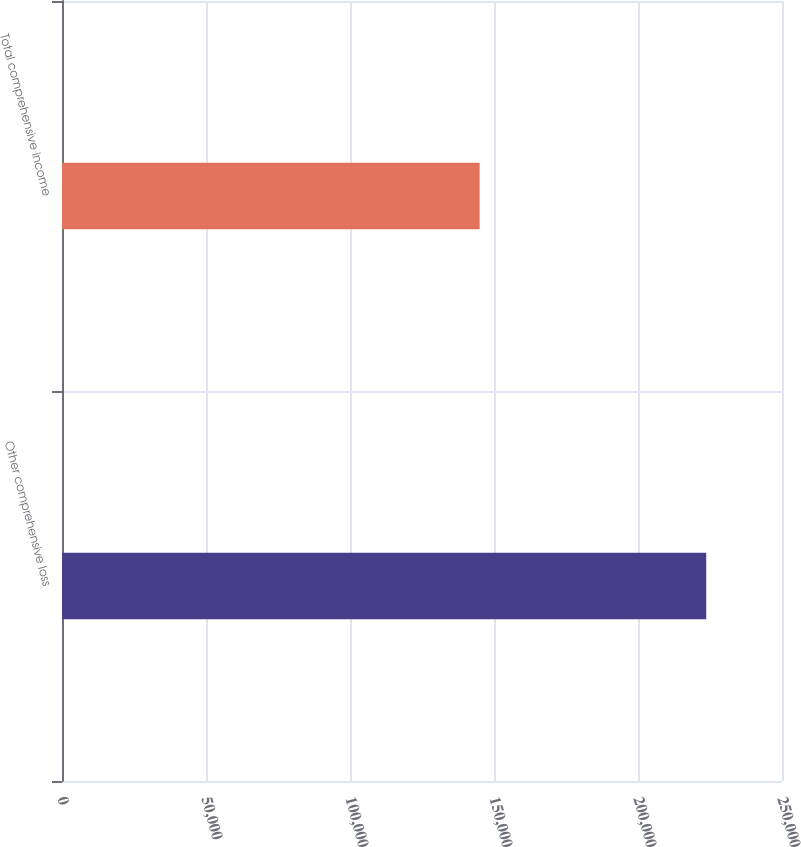Convert chart to OTSL. <chart><loc_0><loc_0><loc_500><loc_500><bar_chart><fcel>Other comprehensive loss<fcel>Total comprehensive income<nl><fcel>223691<fcel>145016<nl></chart> 